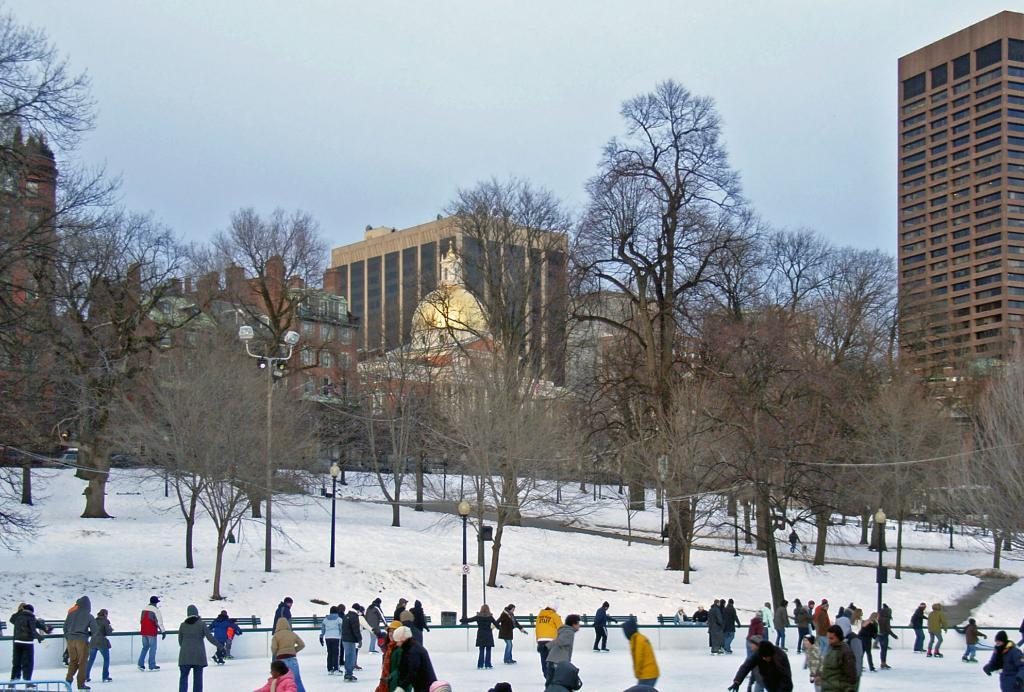What activity are the people in the image engaged in? People are skating on the surface of the snow in the image. What can be seen illuminated in the image? There are lights visible in the image. What type of natural elements can be seen in the background of the image? There are trees in the background of the image. What type of man-made structures can be seen in the background of the image? There are buildings and a statue in the background of the image. What is visible in the sky in the image? The sky is visible in the background of the image. Where is the kitty playing in the image? There is no kitty present in the image. Is there a yard visible in the image? The image does not show a yard; it features people skating on the snow and various background elements. 